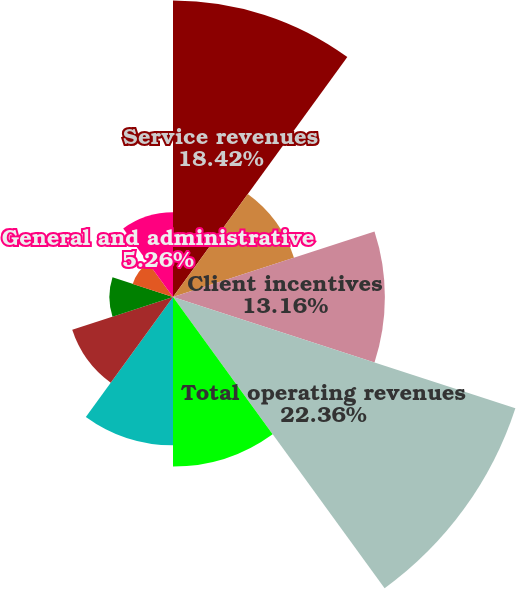Convert chart to OTSL. <chart><loc_0><loc_0><loc_500><loc_500><pie_chart><fcel>Service revenues<fcel>Other revenues<fcel>Client incentives<fcel>Total operating revenues<fcel>Personnel<fcel>Marketing<fcel>Network and processing<fcel>Professional fees<fcel>Depreciation and amortization<fcel>General and administrative<nl><fcel>18.42%<fcel>7.9%<fcel>13.16%<fcel>22.36%<fcel>10.53%<fcel>9.21%<fcel>6.58%<fcel>3.95%<fcel>2.63%<fcel>5.26%<nl></chart> 